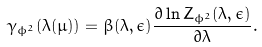Convert formula to latex. <formula><loc_0><loc_0><loc_500><loc_500>\gamma _ { \phi ^ { 2 } } ( \lambda ( \mu ) ) = \beta ( \lambda , \epsilon ) \frac { \partial \ln Z _ { \phi ^ { 2 } } ( \lambda , \epsilon ) } { \partial \lambda } .</formula> 